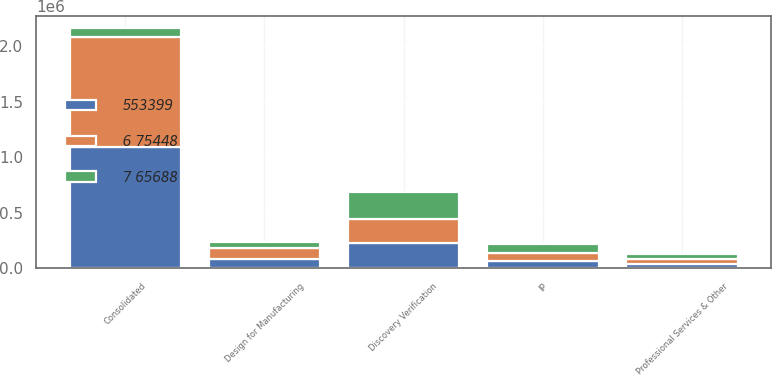Convert chart to OTSL. <chart><loc_0><loc_0><loc_500><loc_500><stacked_bar_chart><ecel><fcel>Discovery Verification<fcel>IP<fcel>Design for Manufacturing<fcel>Professional Services & Other<fcel>Consolidated<nl><fcel>6 75448<fcel>215925<fcel>72118<fcel>101575<fcel>48914<fcel>991931<nl><fcel>553399<fcel>225469<fcel>70684<fcel>81646<fcel>38857<fcel>1.0921e+06<nl><fcel>7 65688<fcel>245914<fcel>74096<fcel>52093<fcel>39192<fcel>77871<nl></chart> 